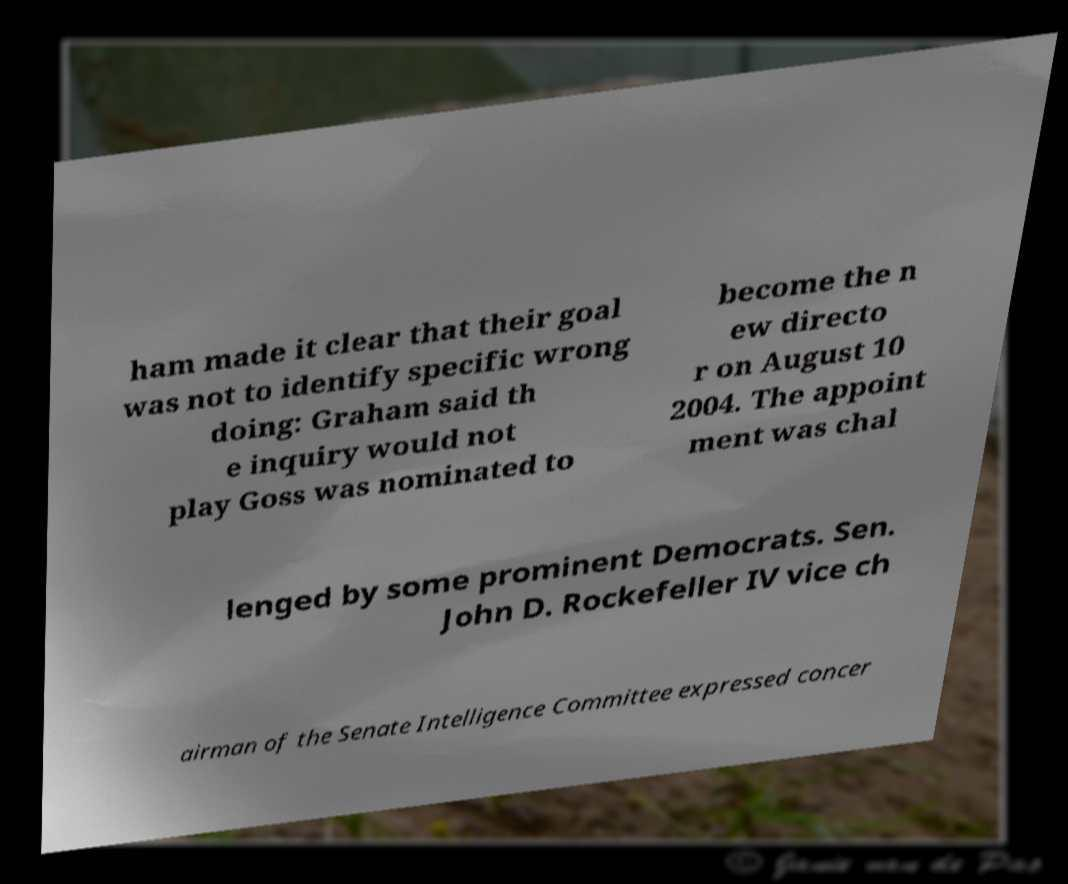Can you accurately transcribe the text from the provided image for me? ham made it clear that their goal was not to identify specific wrong doing: Graham said th e inquiry would not play Goss was nominated to become the n ew directo r on August 10 2004. The appoint ment was chal lenged by some prominent Democrats. Sen. John D. Rockefeller IV vice ch airman of the Senate Intelligence Committee expressed concer 